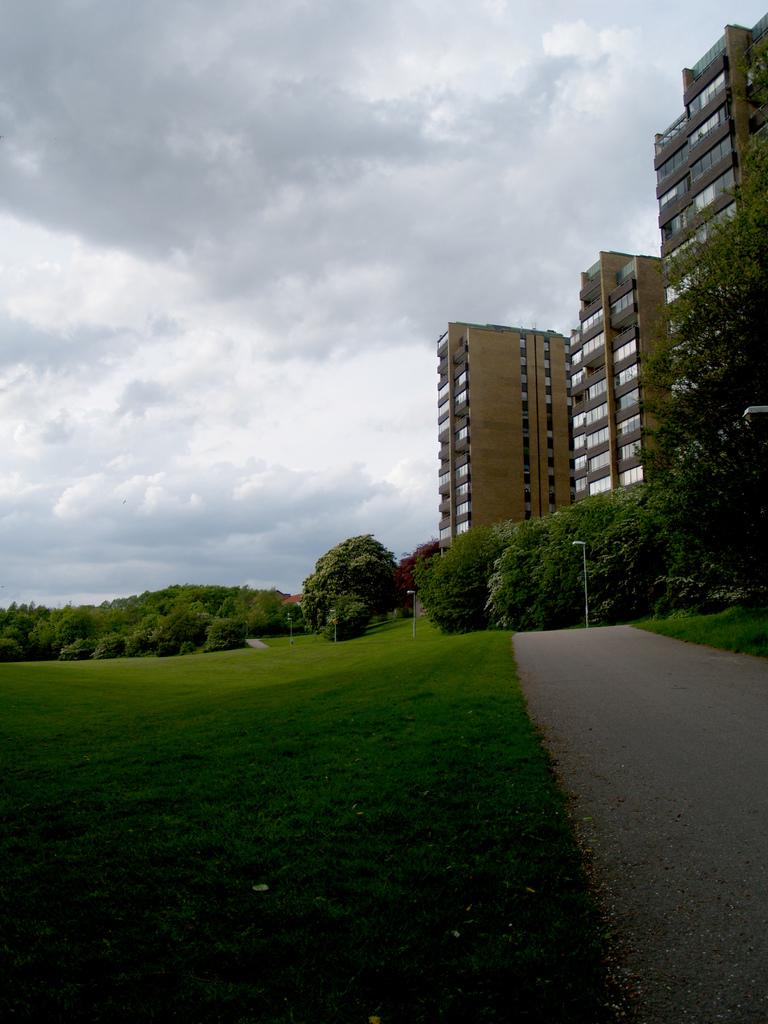What type of vegetation can be seen in the image? There are trees in the image. What type of lighting is present in the image? There are street lights in the image. What type of ground cover is visible in the image? There is grass in the image. What type of buildings are present in the image? There are buildings with glass doors in the image. What type of walkway is present in the image? There is a pathway in the image. What is visible in the sky in the image? There are clouds in the sky in the image. What type of pot is visible in the image? There is no pot present in the image. What type of brass object can be seen in the image? There is no brass object present in the image. 